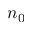Convert formula to latex. <formula><loc_0><loc_0><loc_500><loc_500>n _ { 0 }</formula> 